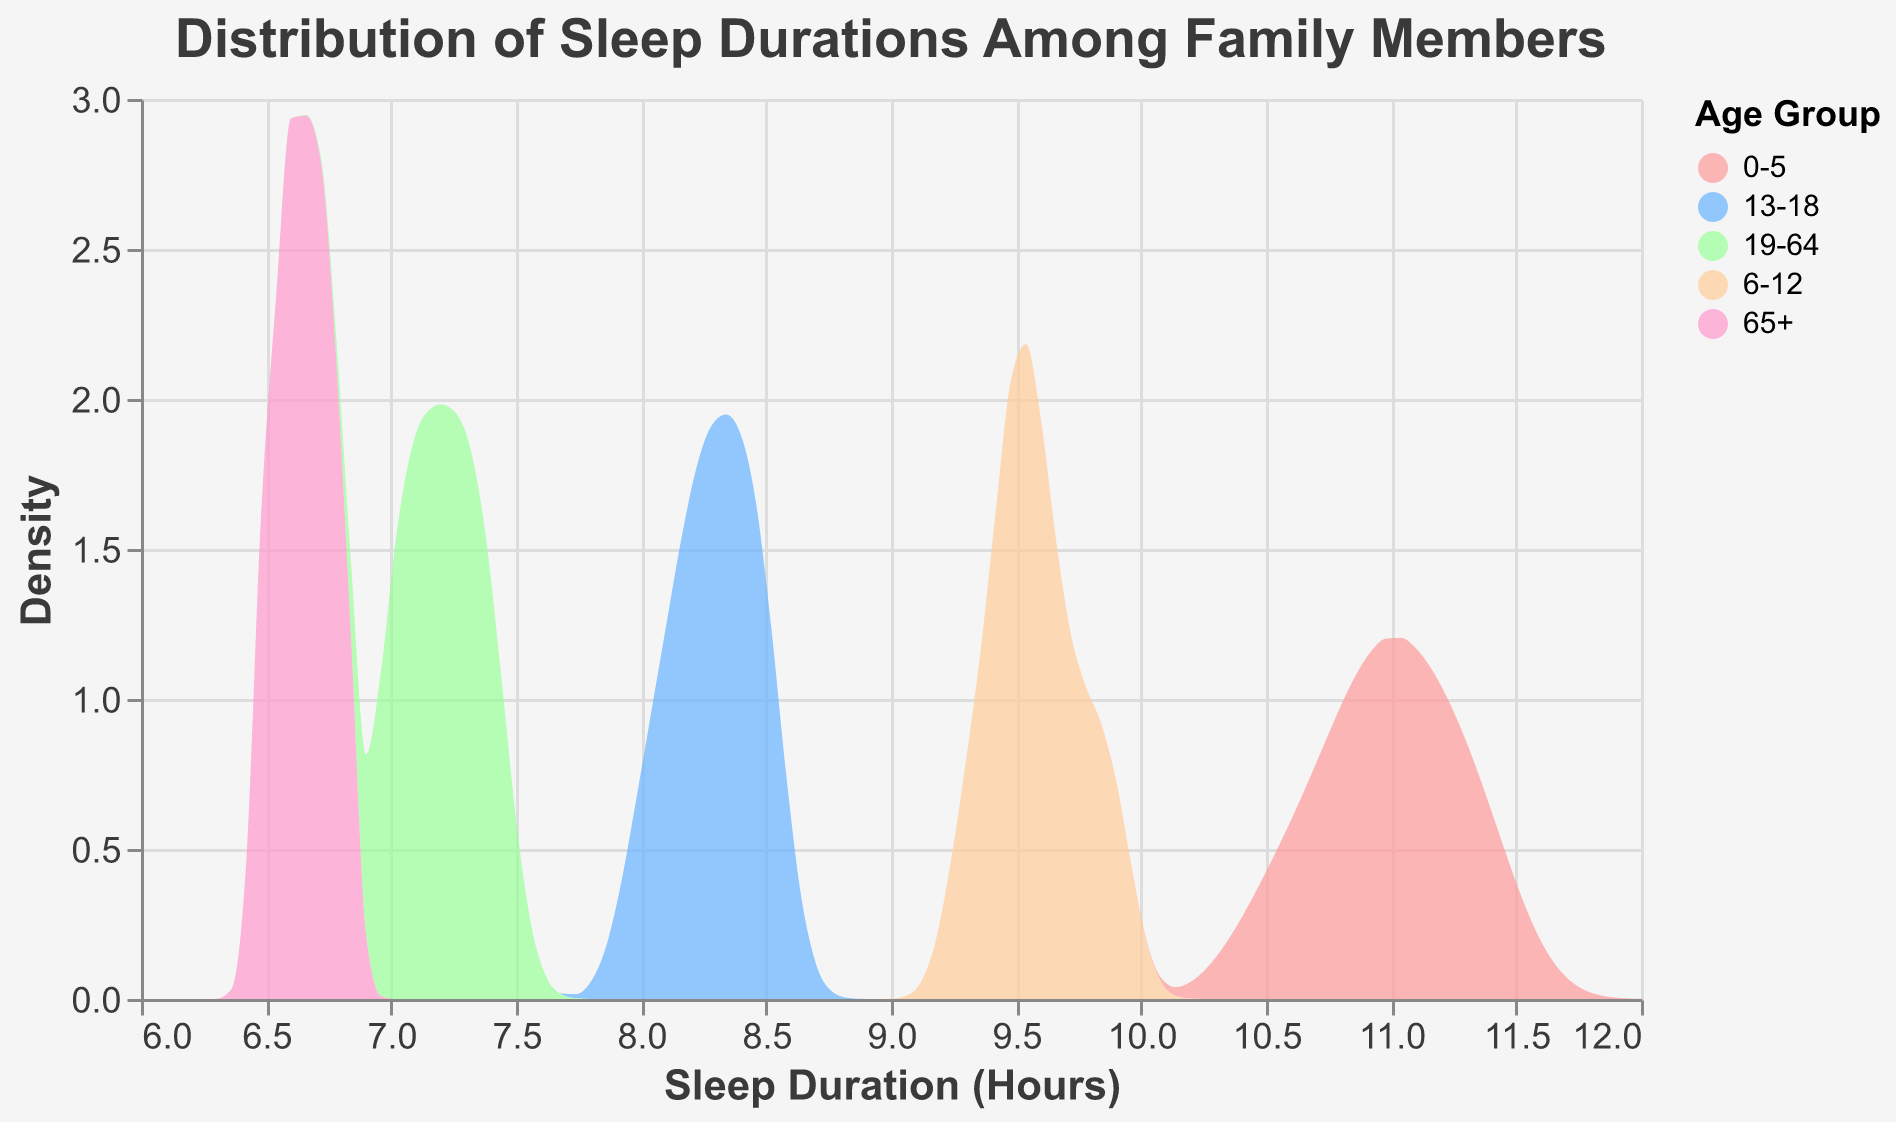What is the range of sleep duration for the 19-64 age group? The range is calculated by finding the difference between the maximum and minimum sleep durations for the 19-64 age group. From the figure, the minimum sleep duration is 7.0 hours, and the maximum is 7.4 hours. The range is 7.4 - 7.0 = 0.4 hours.
Answer: 0.4 hours Which age group has the highest average sleep duration? By examining the peak and the spread of the distributions, you can estimate that the 0-5 age group has the highest average sleep duration since its density curve is the highest and most spread towards the larger sleep durations.
Answer: 0-5 age group Which age group shows the most variability in sleep duration? Observing the width of the density plot for each age group, the 0-5 age group seems to have the most spread out sleep durations, indicating the highest variability.
Answer: 0-5 age group Which two age groups have the closest peak sleep durations? By observing the peaks of the density plots, the 19-64 and 65+ age groups have very close peak sleep durations around 7 hours.
Answer: 19-64 and 65+ age groups What is the approximate sleep duration at the peak density for the 13-18 age group? The peak of the density plot for the 13-18 age group appears to be around 8.3 hours. You can identify this by locating the highest point in the area specific to the 13-18 group.
Answer: 8.3 hours In which age group does the median sleep duration decrease most noticeably compared to the preceding age group? By comparing median sleep durations between the plotted age groups, you can infer that the most noticeable drop occurs from the 0-5 to the 6-12 age group as the peak shifts significantly leftward.
Answer: From 0-5 to 6-12 age group Which age group has the smallest spread in sleep durations? The age group with the least spread in its density plot indicates the smallest variability. From the figure, the 19-64 and 65+ groups appear to have the smallest spreads.
Answer: 19-64 and 65+ How does the sleep duration for the 6-12 age group compare to the 13-18 age group? By observing the peaks and spread of the density plots for these two age groups, you can determine that the 6-12 age group generally sleeps longer, as the peak for 6-12 is around 9.5-9.9 hours, higher than the 8.0-8.5 hours of the 13-18 age group.
Answer: The 6-12 age group generally sleeps longer Which age group shows a significant peak around 9.5 hours of sleep? The density plot for the 6-12 age group shows a notable peak around 9.5 hours of sleep, indicating that this age group often sleeps for about 9.5 hours.
Answer: 6-12 age group Between the 0-5 and 13-18 age groups, which one has a higher peak density? Comparing the height of the density peaks of these two age groups, the 0-5 age group has a higher peak density than the 13-18 age group, indicating a high concentration of specific sleep duration.
Answer: 0-5 age group 